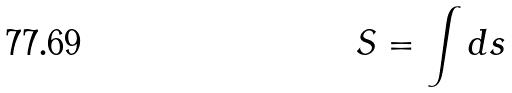<formula> <loc_0><loc_0><loc_500><loc_500>S = \int d s</formula> 